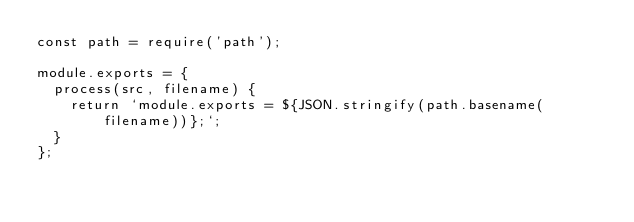Convert code to text. <code><loc_0><loc_0><loc_500><loc_500><_JavaScript_>const path = require('path');

module.exports = {
  process(src, filename) {
    return `module.exports = ${JSON.stringify(path.basename(filename))};`;
  }
};
</code> 